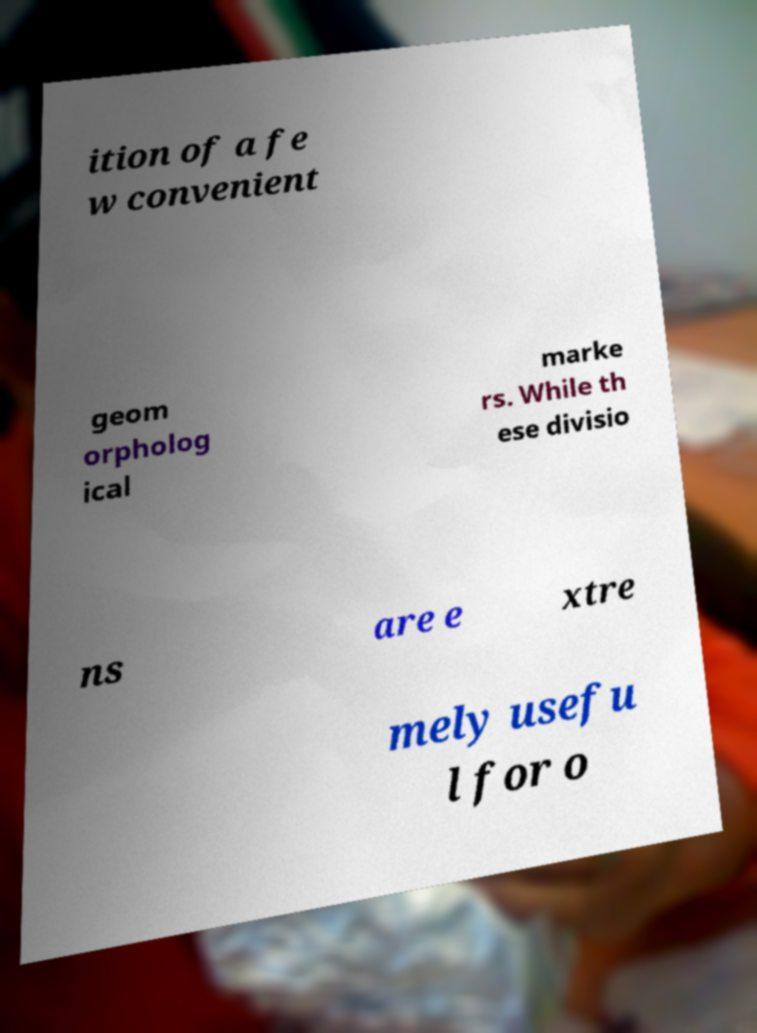There's text embedded in this image that I need extracted. Can you transcribe it verbatim? ition of a fe w convenient geom orpholog ical marke rs. While th ese divisio ns are e xtre mely usefu l for o 